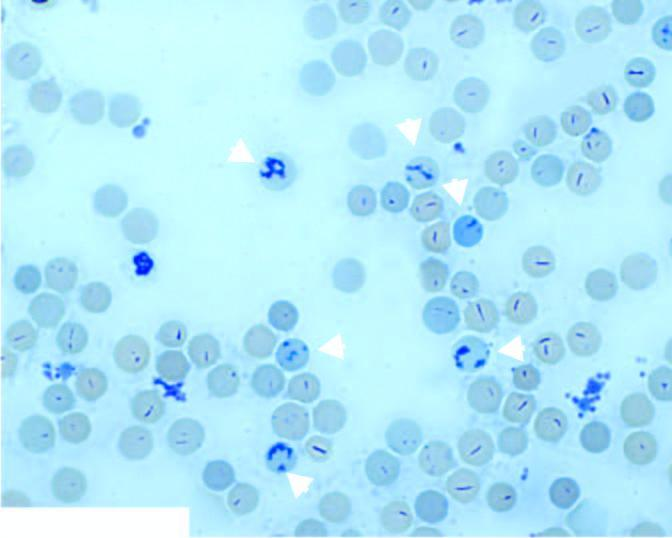s eticulocytes in blood as seen in blood stained by supravital dye, new methylene blue?
Answer the question using a single word or phrase. Yes 